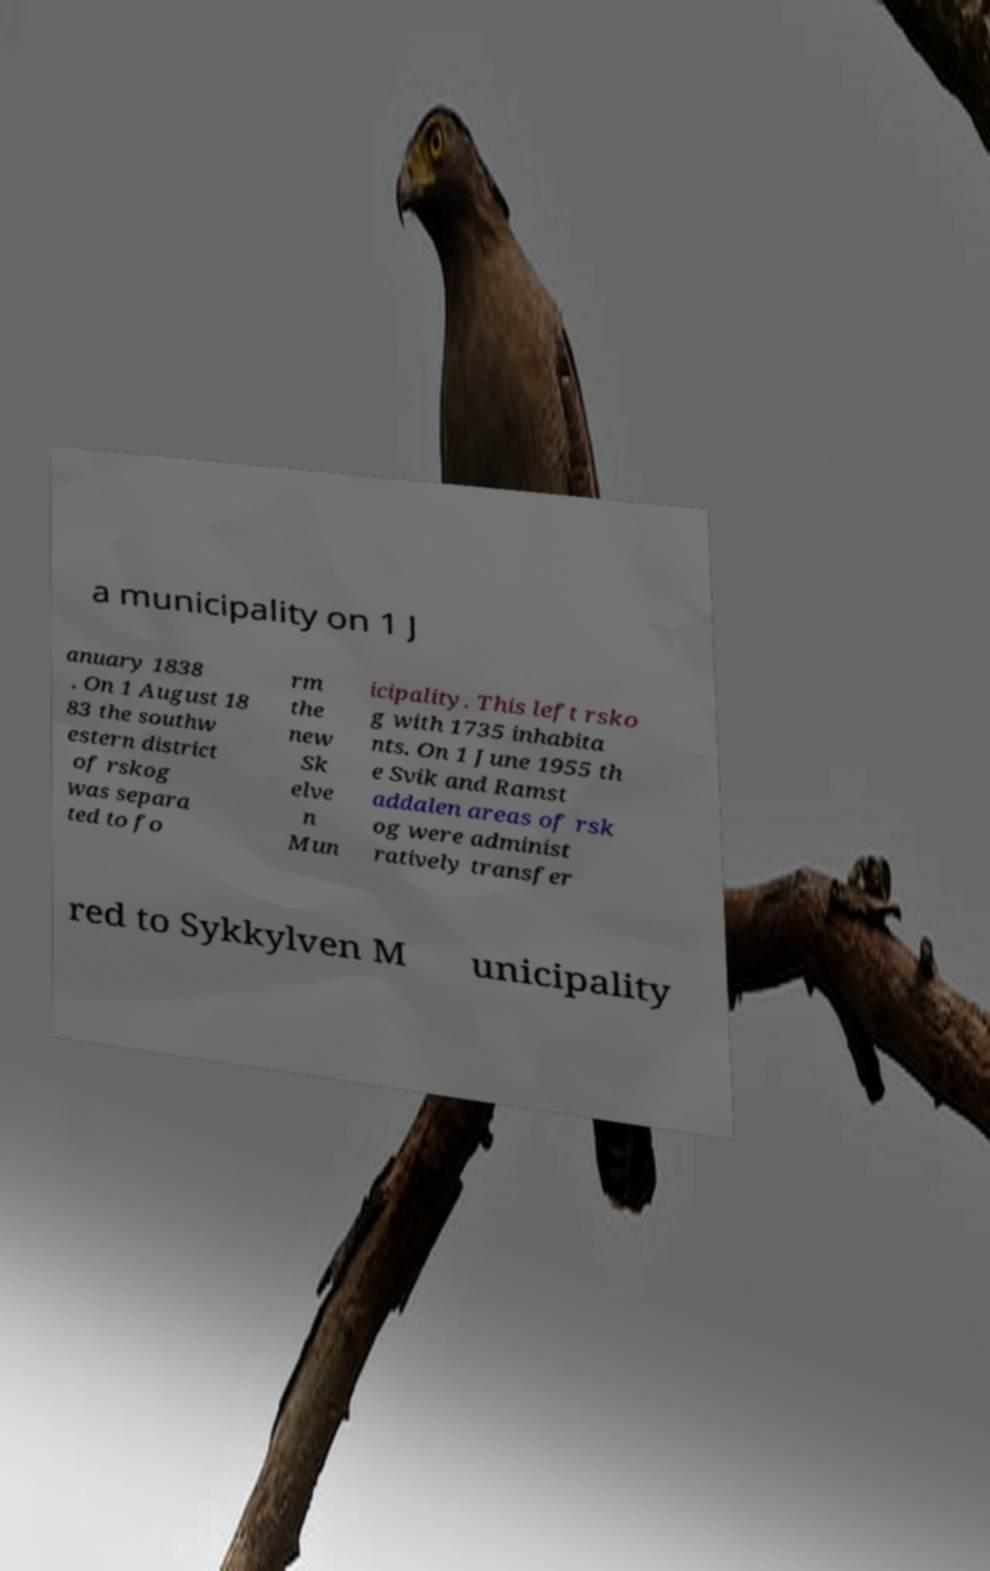Please identify and transcribe the text found in this image. a municipality on 1 J anuary 1838 . On 1 August 18 83 the southw estern district of rskog was separa ted to fo rm the new Sk elve n Mun icipality. This left rsko g with 1735 inhabita nts. On 1 June 1955 th e Svik and Ramst addalen areas of rsk og were administ ratively transfer red to Sykkylven M unicipality 